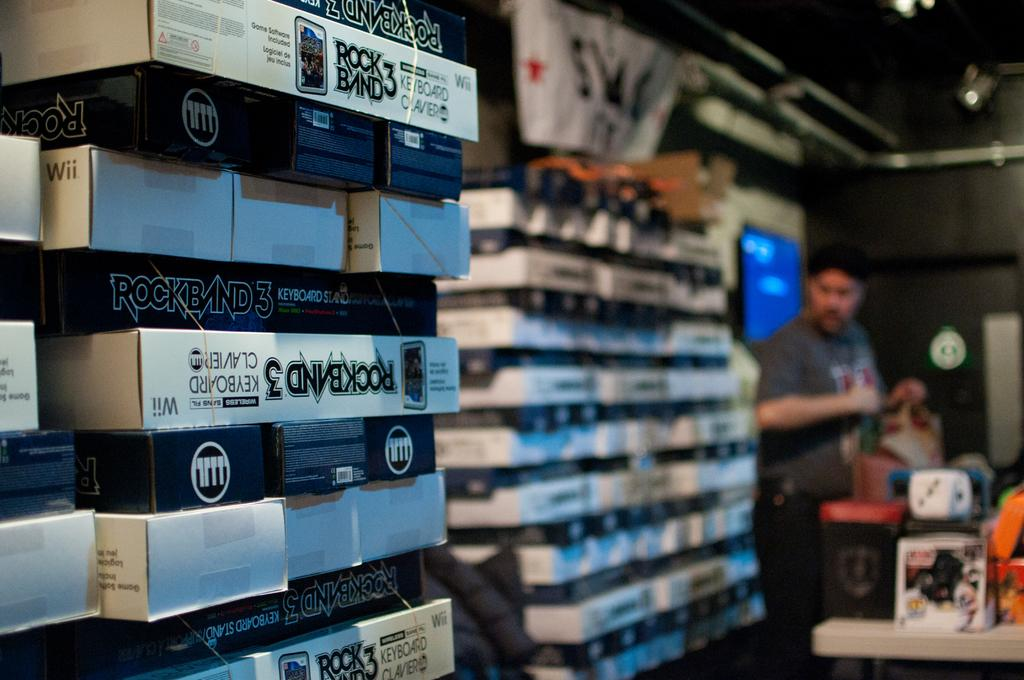Provide a one-sentence caption for the provided image. A stack of merchandise for the video game Rock Band 3. 